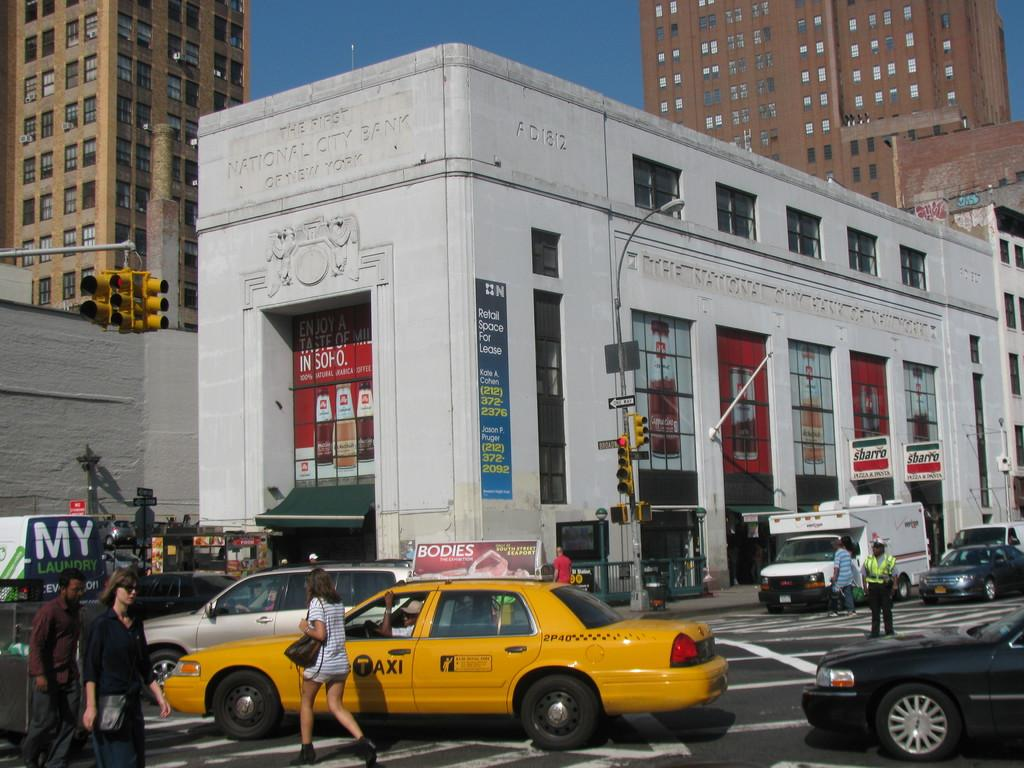Provide a one-sentence caption for the provided image. People walk across a crosswalk in front of a yellow taxi in the city. 